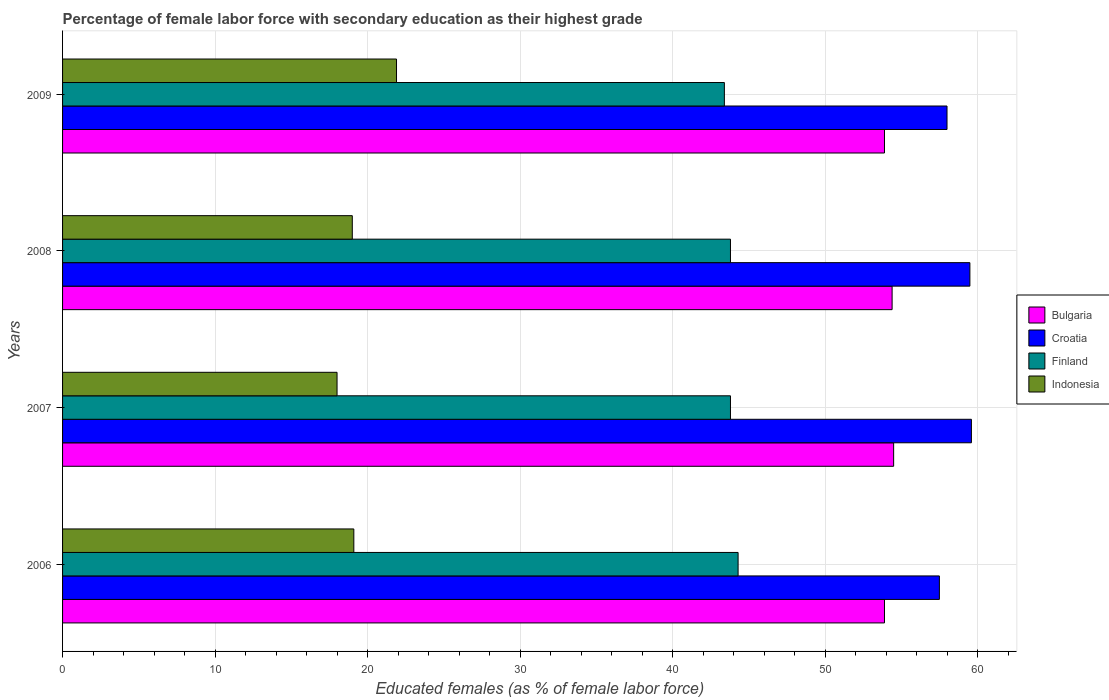How many different coloured bars are there?
Your answer should be very brief. 4. In how many cases, is the number of bars for a given year not equal to the number of legend labels?
Your answer should be compact. 0. What is the percentage of female labor force with secondary education in Finland in 2007?
Your answer should be very brief. 43.8. Across all years, what is the maximum percentage of female labor force with secondary education in Bulgaria?
Your answer should be very brief. 54.5. In which year was the percentage of female labor force with secondary education in Bulgaria maximum?
Provide a succinct answer. 2007. What is the total percentage of female labor force with secondary education in Finland in the graph?
Your answer should be very brief. 175.3. What is the difference between the percentage of female labor force with secondary education in Bulgaria in 2007 and that in 2009?
Make the answer very short. 0.6. What is the difference between the percentage of female labor force with secondary education in Croatia in 2009 and the percentage of female labor force with secondary education in Bulgaria in 2008?
Keep it short and to the point. 3.6. What is the average percentage of female labor force with secondary education in Bulgaria per year?
Offer a terse response. 54.18. In the year 2009, what is the difference between the percentage of female labor force with secondary education in Bulgaria and percentage of female labor force with secondary education in Indonesia?
Your response must be concise. 32. Is the difference between the percentage of female labor force with secondary education in Bulgaria in 2008 and 2009 greater than the difference between the percentage of female labor force with secondary education in Indonesia in 2008 and 2009?
Your answer should be compact. Yes. What is the difference between the highest and the second highest percentage of female labor force with secondary education in Indonesia?
Your response must be concise. 2.8. What is the difference between the highest and the lowest percentage of female labor force with secondary education in Croatia?
Your answer should be compact. 2.1. In how many years, is the percentage of female labor force with secondary education in Croatia greater than the average percentage of female labor force with secondary education in Croatia taken over all years?
Your answer should be very brief. 2. Is the sum of the percentage of female labor force with secondary education in Bulgaria in 2006 and 2008 greater than the maximum percentage of female labor force with secondary education in Indonesia across all years?
Offer a terse response. Yes. Is it the case that in every year, the sum of the percentage of female labor force with secondary education in Croatia and percentage of female labor force with secondary education in Finland is greater than the sum of percentage of female labor force with secondary education in Indonesia and percentage of female labor force with secondary education in Bulgaria?
Provide a succinct answer. Yes. What does the 2nd bar from the bottom in 2009 represents?
Offer a very short reply. Croatia. Are all the bars in the graph horizontal?
Offer a terse response. Yes. What is the difference between two consecutive major ticks on the X-axis?
Offer a very short reply. 10. Does the graph contain grids?
Keep it short and to the point. Yes. Where does the legend appear in the graph?
Make the answer very short. Center right. How many legend labels are there?
Offer a very short reply. 4. What is the title of the graph?
Give a very brief answer. Percentage of female labor force with secondary education as their highest grade. What is the label or title of the X-axis?
Provide a short and direct response. Educated females (as % of female labor force). What is the Educated females (as % of female labor force) in Bulgaria in 2006?
Offer a very short reply. 53.9. What is the Educated females (as % of female labor force) of Croatia in 2006?
Your answer should be very brief. 57.5. What is the Educated females (as % of female labor force) of Finland in 2006?
Offer a terse response. 44.3. What is the Educated females (as % of female labor force) in Indonesia in 2006?
Offer a very short reply. 19.1. What is the Educated females (as % of female labor force) of Bulgaria in 2007?
Ensure brevity in your answer.  54.5. What is the Educated females (as % of female labor force) of Croatia in 2007?
Ensure brevity in your answer.  59.6. What is the Educated females (as % of female labor force) in Finland in 2007?
Provide a succinct answer. 43.8. What is the Educated females (as % of female labor force) in Indonesia in 2007?
Provide a succinct answer. 18. What is the Educated females (as % of female labor force) in Bulgaria in 2008?
Offer a terse response. 54.4. What is the Educated females (as % of female labor force) in Croatia in 2008?
Provide a succinct answer. 59.5. What is the Educated females (as % of female labor force) in Finland in 2008?
Keep it short and to the point. 43.8. What is the Educated females (as % of female labor force) in Indonesia in 2008?
Ensure brevity in your answer.  19. What is the Educated females (as % of female labor force) in Bulgaria in 2009?
Give a very brief answer. 53.9. What is the Educated females (as % of female labor force) of Croatia in 2009?
Make the answer very short. 58. What is the Educated females (as % of female labor force) of Finland in 2009?
Provide a short and direct response. 43.4. What is the Educated females (as % of female labor force) of Indonesia in 2009?
Ensure brevity in your answer.  21.9. Across all years, what is the maximum Educated females (as % of female labor force) of Bulgaria?
Ensure brevity in your answer.  54.5. Across all years, what is the maximum Educated females (as % of female labor force) in Croatia?
Your response must be concise. 59.6. Across all years, what is the maximum Educated females (as % of female labor force) of Finland?
Give a very brief answer. 44.3. Across all years, what is the maximum Educated females (as % of female labor force) of Indonesia?
Provide a succinct answer. 21.9. Across all years, what is the minimum Educated females (as % of female labor force) of Bulgaria?
Your answer should be compact. 53.9. Across all years, what is the minimum Educated females (as % of female labor force) in Croatia?
Offer a very short reply. 57.5. Across all years, what is the minimum Educated females (as % of female labor force) in Finland?
Provide a short and direct response. 43.4. What is the total Educated females (as % of female labor force) of Bulgaria in the graph?
Offer a terse response. 216.7. What is the total Educated females (as % of female labor force) of Croatia in the graph?
Keep it short and to the point. 234.6. What is the total Educated females (as % of female labor force) in Finland in the graph?
Provide a short and direct response. 175.3. What is the total Educated females (as % of female labor force) of Indonesia in the graph?
Keep it short and to the point. 78. What is the difference between the Educated females (as % of female labor force) in Bulgaria in 2006 and that in 2008?
Offer a terse response. -0.5. What is the difference between the Educated females (as % of female labor force) of Croatia in 2006 and that in 2008?
Provide a succinct answer. -2. What is the difference between the Educated females (as % of female labor force) in Finland in 2006 and that in 2008?
Provide a succinct answer. 0.5. What is the difference between the Educated females (as % of female labor force) of Indonesia in 2006 and that in 2008?
Keep it short and to the point. 0.1. What is the difference between the Educated females (as % of female labor force) in Finland in 2006 and that in 2009?
Provide a succinct answer. 0.9. What is the difference between the Educated females (as % of female labor force) of Bulgaria in 2007 and that in 2008?
Provide a succinct answer. 0.1. What is the difference between the Educated females (as % of female labor force) of Croatia in 2007 and that in 2008?
Your answer should be very brief. 0.1. What is the difference between the Educated females (as % of female labor force) of Indonesia in 2007 and that in 2008?
Your answer should be very brief. -1. What is the difference between the Educated females (as % of female labor force) in Finland in 2007 and that in 2009?
Your answer should be compact. 0.4. What is the difference between the Educated females (as % of female labor force) in Indonesia in 2008 and that in 2009?
Your response must be concise. -2.9. What is the difference between the Educated females (as % of female labor force) of Bulgaria in 2006 and the Educated females (as % of female labor force) of Croatia in 2007?
Make the answer very short. -5.7. What is the difference between the Educated females (as % of female labor force) of Bulgaria in 2006 and the Educated females (as % of female labor force) of Indonesia in 2007?
Provide a short and direct response. 35.9. What is the difference between the Educated females (as % of female labor force) of Croatia in 2006 and the Educated females (as % of female labor force) of Finland in 2007?
Your answer should be compact. 13.7. What is the difference between the Educated females (as % of female labor force) of Croatia in 2006 and the Educated females (as % of female labor force) of Indonesia in 2007?
Your answer should be compact. 39.5. What is the difference between the Educated females (as % of female labor force) of Finland in 2006 and the Educated females (as % of female labor force) of Indonesia in 2007?
Offer a terse response. 26.3. What is the difference between the Educated females (as % of female labor force) in Bulgaria in 2006 and the Educated females (as % of female labor force) in Indonesia in 2008?
Provide a short and direct response. 34.9. What is the difference between the Educated females (as % of female labor force) of Croatia in 2006 and the Educated females (as % of female labor force) of Finland in 2008?
Your answer should be compact. 13.7. What is the difference between the Educated females (as % of female labor force) in Croatia in 2006 and the Educated females (as % of female labor force) in Indonesia in 2008?
Your answer should be very brief. 38.5. What is the difference between the Educated females (as % of female labor force) in Finland in 2006 and the Educated females (as % of female labor force) in Indonesia in 2008?
Ensure brevity in your answer.  25.3. What is the difference between the Educated females (as % of female labor force) of Bulgaria in 2006 and the Educated females (as % of female labor force) of Finland in 2009?
Ensure brevity in your answer.  10.5. What is the difference between the Educated females (as % of female labor force) of Croatia in 2006 and the Educated females (as % of female labor force) of Indonesia in 2009?
Keep it short and to the point. 35.6. What is the difference between the Educated females (as % of female labor force) of Finland in 2006 and the Educated females (as % of female labor force) of Indonesia in 2009?
Provide a succinct answer. 22.4. What is the difference between the Educated females (as % of female labor force) in Bulgaria in 2007 and the Educated females (as % of female labor force) in Croatia in 2008?
Keep it short and to the point. -5. What is the difference between the Educated females (as % of female labor force) of Bulgaria in 2007 and the Educated females (as % of female labor force) of Indonesia in 2008?
Ensure brevity in your answer.  35.5. What is the difference between the Educated females (as % of female labor force) of Croatia in 2007 and the Educated females (as % of female labor force) of Finland in 2008?
Provide a succinct answer. 15.8. What is the difference between the Educated females (as % of female labor force) of Croatia in 2007 and the Educated females (as % of female labor force) of Indonesia in 2008?
Give a very brief answer. 40.6. What is the difference between the Educated females (as % of female labor force) of Finland in 2007 and the Educated females (as % of female labor force) of Indonesia in 2008?
Your answer should be very brief. 24.8. What is the difference between the Educated females (as % of female labor force) in Bulgaria in 2007 and the Educated females (as % of female labor force) in Finland in 2009?
Ensure brevity in your answer.  11.1. What is the difference between the Educated females (as % of female labor force) in Bulgaria in 2007 and the Educated females (as % of female labor force) in Indonesia in 2009?
Provide a succinct answer. 32.6. What is the difference between the Educated females (as % of female labor force) in Croatia in 2007 and the Educated females (as % of female labor force) in Indonesia in 2009?
Your answer should be very brief. 37.7. What is the difference between the Educated females (as % of female labor force) in Finland in 2007 and the Educated females (as % of female labor force) in Indonesia in 2009?
Give a very brief answer. 21.9. What is the difference between the Educated females (as % of female labor force) of Bulgaria in 2008 and the Educated females (as % of female labor force) of Indonesia in 2009?
Offer a very short reply. 32.5. What is the difference between the Educated females (as % of female labor force) of Croatia in 2008 and the Educated females (as % of female labor force) of Indonesia in 2009?
Your answer should be compact. 37.6. What is the difference between the Educated females (as % of female labor force) of Finland in 2008 and the Educated females (as % of female labor force) of Indonesia in 2009?
Your response must be concise. 21.9. What is the average Educated females (as % of female labor force) in Bulgaria per year?
Your answer should be compact. 54.17. What is the average Educated females (as % of female labor force) in Croatia per year?
Your answer should be very brief. 58.65. What is the average Educated females (as % of female labor force) of Finland per year?
Make the answer very short. 43.83. In the year 2006, what is the difference between the Educated females (as % of female labor force) in Bulgaria and Educated females (as % of female labor force) in Croatia?
Give a very brief answer. -3.6. In the year 2006, what is the difference between the Educated females (as % of female labor force) of Bulgaria and Educated females (as % of female labor force) of Finland?
Offer a terse response. 9.6. In the year 2006, what is the difference between the Educated females (as % of female labor force) in Bulgaria and Educated females (as % of female labor force) in Indonesia?
Your answer should be very brief. 34.8. In the year 2006, what is the difference between the Educated females (as % of female labor force) of Croatia and Educated females (as % of female labor force) of Finland?
Provide a short and direct response. 13.2. In the year 2006, what is the difference between the Educated females (as % of female labor force) of Croatia and Educated females (as % of female labor force) of Indonesia?
Keep it short and to the point. 38.4. In the year 2006, what is the difference between the Educated females (as % of female labor force) in Finland and Educated females (as % of female labor force) in Indonesia?
Ensure brevity in your answer.  25.2. In the year 2007, what is the difference between the Educated females (as % of female labor force) of Bulgaria and Educated females (as % of female labor force) of Indonesia?
Offer a terse response. 36.5. In the year 2007, what is the difference between the Educated females (as % of female labor force) of Croatia and Educated females (as % of female labor force) of Indonesia?
Offer a very short reply. 41.6. In the year 2007, what is the difference between the Educated females (as % of female labor force) in Finland and Educated females (as % of female labor force) in Indonesia?
Offer a very short reply. 25.8. In the year 2008, what is the difference between the Educated females (as % of female labor force) in Bulgaria and Educated females (as % of female labor force) in Indonesia?
Keep it short and to the point. 35.4. In the year 2008, what is the difference between the Educated females (as % of female labor force) of Croatia and Educated females (as % of female labor force) of Indonesia?
Ensure brevity in your answer.  40.5. In the year 2008, what is the difference between the Educated females (as % of female labor force) of Finland and Educated females (as % of female labor force) of Indonesia?
Make the answer very short. 24.8. In the year 2009, what is the difference between the Educated females (as % of female labor force) of Bulgaria and Educated females (as % of female labor force) of Croatia?
Your response must be concise. -4.1. In the year 2009, what is the difference between the Educated females (as % of female labor force) of Bulgaria and Educated females (as % of female labor force) of Finland?
Your response must be concise. 10.5. In the year 2009, what is the difference between the Educated females (as % of female labor force) of Bulgaria and Educated females (as % of female labor force) of Indonesia?
Your answer should be compact. 32. In the year 2009, what is the difference between the Educated females (as % of female labor force) of Croatia and Educated females (as % of female labor force) of Indonesia?
Keep it short and to the point. 36.1. What is the ratio of the Educated females (as % of female labor force) of Croatia in 2006 to that in 2007?
Keep it short and to the point. 0.96. What is the ratio of the Educated females (as % of female labor force) of Finland in 2006 to that in 2007?
Provide a short and direct response. 1.01. What is the ratio of the Educated females (as % of female labor force) of Indonesia in 2006 to that in 2007?
Your answer should be compact. 1.06. What is the ratio of the Educated females (as % of female labor force) in Bulgaria in 2006 to that in 2008?
Ensure brevity in your answer.  0.99. What is the ratio of the Educated females (as % of female labor force) in Croatia in 2006 to that in 2008?
Your response must be concise. 0.97. What is the ratio of the Educated females (as % of female labor force) of Finland in 2006 to that in 2008?
Provide a short and direct response. 1.01. What is the ratio of the Educated females (as % of female labor force) of Croatia in 2006 to that in 2009?
Your answer should be compact. 0.99. What is the ratio of the Educated females (as % of female labor force) of Finland in 2006 to that in 2009?
Give a very brief answer. 1.02. What is the ratio of the Educated females (as % of female labor force) of Indonesia in 2006 to that in 2009?
Your answer should be compact. 0.87. What is the ratio of the Educated females (as % of female labor force) in Bulgaria in 2007 to that in 2008?
Give a very brief answer. 1. What is the ratio of the Educated females (as % of female labor force) in Croatia in 2007 to that in 2008?
Offer a terse response. 1. What is the ratio of the Educated females (as % of female labor force) of Indonesia in 2007 to that in 2008?
Make the answer very short. 0.95. What is the ratio of the Educated females (as % of female labor force) of Bulgaria in 2007 to that in 2009?
Your answer should be very brief. 1.01. What is the ratio of the Educated females (as % of female labor force) of Croatia in 2007 to that in 2009?
Your answer should be very brief. 1.03. What is the ratio of the Educated females (as % of female labor force) of Finland in 2007 to that in 2009?
Keep it short and to the point. 1.01. What is the ratio of the Educated females (as % of female labor force) of Indonesia in 2007 to that in 2009?
Your response must be concise. 0.82. What is the ratio of the Educated females (as % of female labor force) in Bulgaria in 2008 to that in 2009?
Keep it short and to the point. 1.01. What is the ratio of the Educated females (as % of female labor force) of Croatia in 2008 to that in 2009?
Offer a very short reply. 1.03. What is the ratio of the Educated females (as % of female labor force) in Finland in 2008 to that in 2009?
Ensure brevity in your answer.  1.01. What is the ratio of the Educated females (as % of female labor force) in Indonesia in 2008 to that in 2009?
Ensure brevity in your answer.  0.87. What is the difference between the highest and the second highest Educated females (as % of female labor force) in Croatia?
Give a very brief answer. 0.1. What is the difference between the highest and the second highest Educated females (as % of female labor force) in Finland?
Offer a terse response. 0.5. What is the difference between the highest and the second highest Educated females (as % of female labor force) in Indonesia?
Keep it short and to the point. 2.8. What is the difference between the highest and the lowest Educated females (as % of female labor force) of Croatia?
Your answer should be compact. 2.1. What is the difference between the highest and the lowest Educated females (as % of female labor force) in Indonesia?
Offer a very short reply. 3.9. 